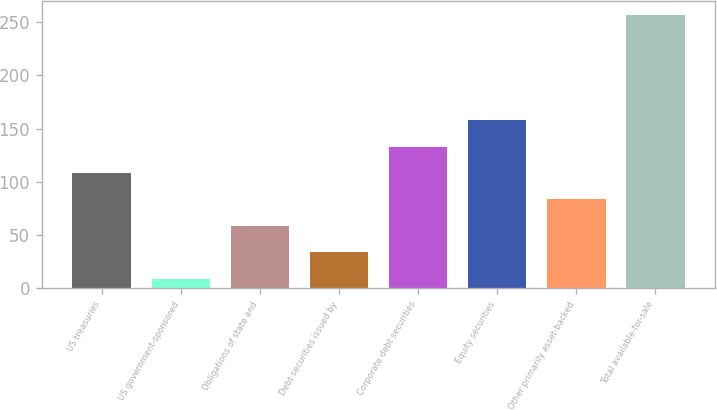<chart> <loc_0><loc_0><loc_500><loc_500><bar_chart><fcel>US treasuries<fcel>US government-sponsored<fcel>Obligations of state and<fcel>Debt securities issued by<fcel>Corporate debt securities<fcel>Equity securities<fcel>Other primarily asset-backed<fcel>Total available-for-sale<nl><fcel>108.2<fcel>9<fcel>58.6<fcel>33.8<fcel>133<fcel>157.8<fcel>83.4<fcel>257<nl></chart> 